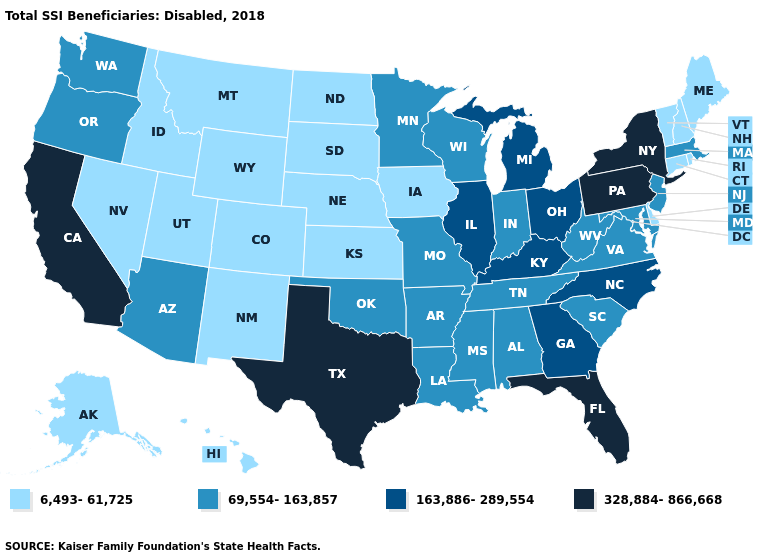Name the states that have a value in the range 6,493-61,725?
Quick response, please. Alaska, Colorado, Connecticut, Delaware, Hawaii, Idaho, Iowa, Kansas, Maine, Montana, Nebraska, Nevada, New Hampshire, New Mexico, North Dakota, Rhode Island, South Dakota, Utah, Vermont, Wyoming. Name the states that have a value in the range 69,554-163,857?
Be succinct. Alabama, Arizona, Arkansas, Indiana, Louisiana, Maryland, Massachusetts, Minnesota, Mississippi, Missouri, New Jersey, Oklahoma, Oregon, South Carolina, Tennessee, Virginia, Washington, West Virginia, Wisconsin. What is the value of West Virginia?
Give a very brief answer. 69,554-163,857. Name the states that have a value in the range 328,884-866,668?
Be succinct. California, Florida, New York, Pennsylvania, Texas. Name the states that have a value in the range 6,493-61,725?
Short answer required. Alaska, Colorado, Connecticut, Delaware, Hawaii, Idaho, Iowa, Kansas, Maine, Montana, Nebraska, Nevada, New Hampshire, New Mexico, North Dakota, Rhode Island, South Dakota, Utah, Vermont, Wyoming. Does Illinois have a lower value than California?
Keep it brief. Yes. Among the states that border Pennsylvania , which have the lowest value?
Be succinct. Delaware. Does Nevada have a lower value than Colorado?
Concise answer only. No. Is the legend a continuous bar?
Concise answer only. No. What is the value of Nebraska?
Keep it brief. 6,493-61,725. What is the value of Illinois?
Short answer required. 163,886-289,554. What is the value of Wisconsin?
Write a very short answer. 69,554-163,857. How many symbols are there in the legend?
Short answer required. 4. Name the states that have a value in the range 6,493-61,725?
Answer briefly. Alaska, Colorado, Connecticut, Delaware, Hawaii, Idaho, Iowa, Kansas, Maine, Montana, Nebraska, Nevada, New Hampshire, New Mexico, North Dakota, Rhode Island, South Dakota, Utah, Vermont, Wyoming. Does the first symbol in the legend represent the smallest category?
Write a very short answer. Yes. 